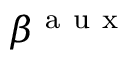Convert formula to latex. <formula><loc_0><loc_0><loc_500><loc_500>\beta ^ { a u x }</formula> 